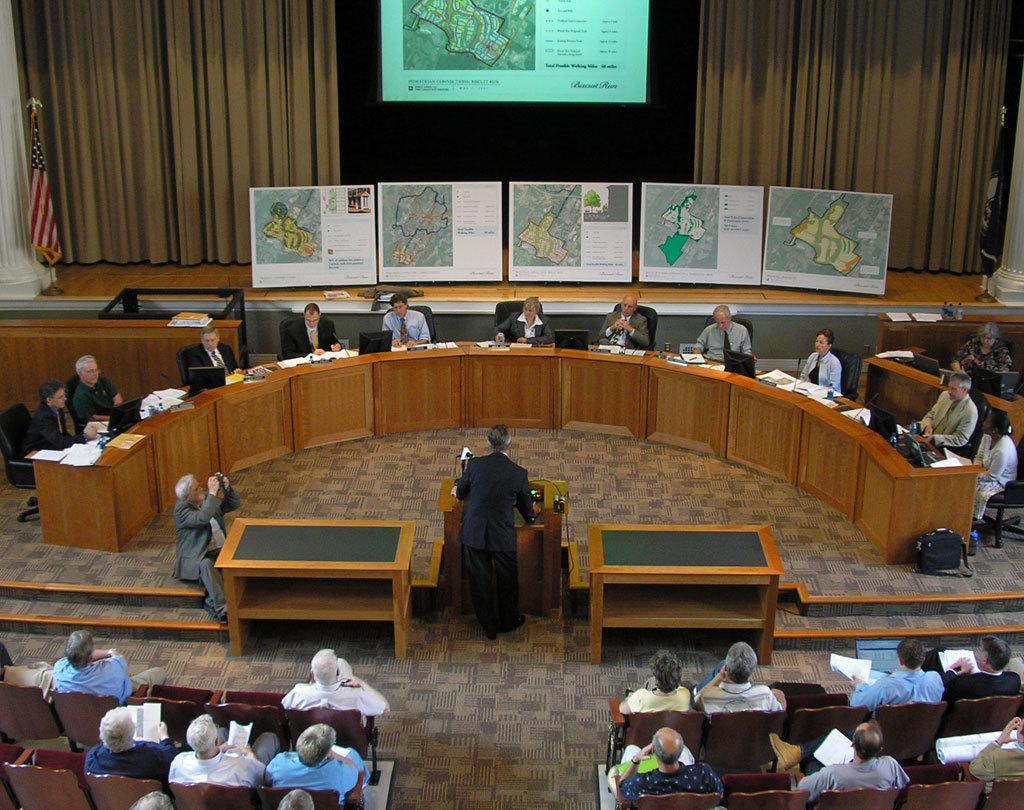Please provide a concise description of this image. There are few persons sitting on the chairs. Here we can see tables, podium, papers, and monitors. There are boards, pillars,and a flag. In the background we can see curtains and a screen. 